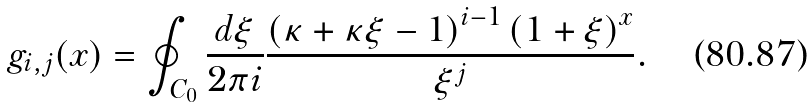<formula> <loc_0><loc_0><loc_500><loc_500>g _ { i , j } ( x ) = \oint _ { C _ { 0 } } \frac { d \xi } { 2 \pi i } \frac { \left ( \kappa + \kappa \xi - 1 \right ) ^ { i - 1 } \left ( 1 + \xi \right ) ^ { x } } { \xi ^ { j } } .</formula> 